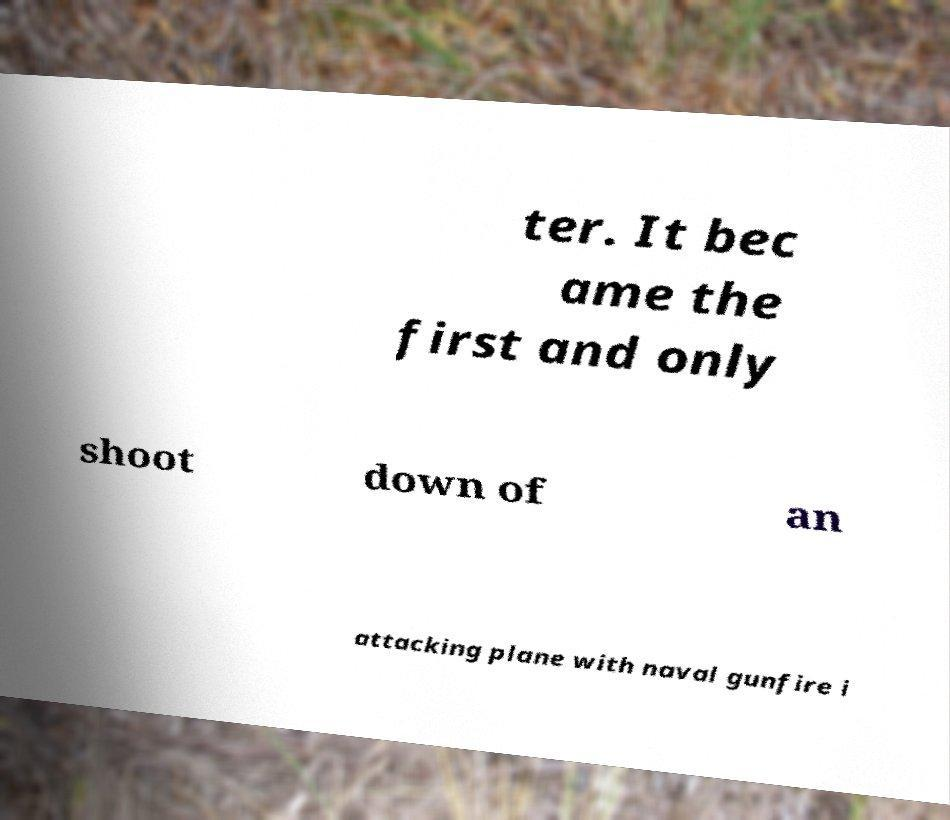Can you accurately transcribe the text from the provided image for me? ter. It bec ame the first and only shoot down of an attacking plane with naval gunfire i 